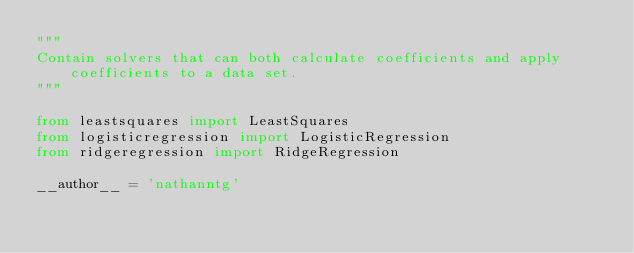Convert code to text. <code><loc_0><loc_0><loc_500><loc_500><_Python_>"""
Contain solvers that can both calculate coefficients and apply coefficients to a data set.
"""

from leastsquares import LeastSquares
from logisticregression import LogisticRegression
from ridgeregression import RidgeRegression

__author__ = 'nathanntg'
</code> 